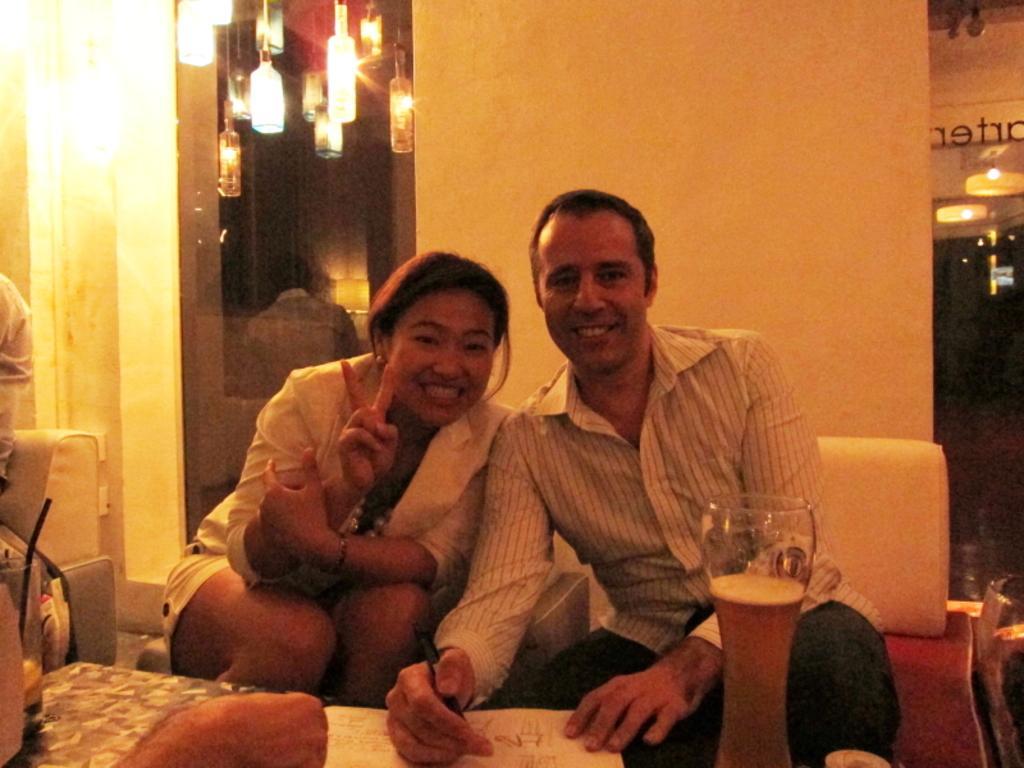Could you give a brief overview of what you see in this image? In this picture there is a man and a woman on the sofa, in the center of the image and there are lamps at the top side of the image, there is a table at the bottom side of the image, on which there is a paper, there is another sofa on the left side of the image. 